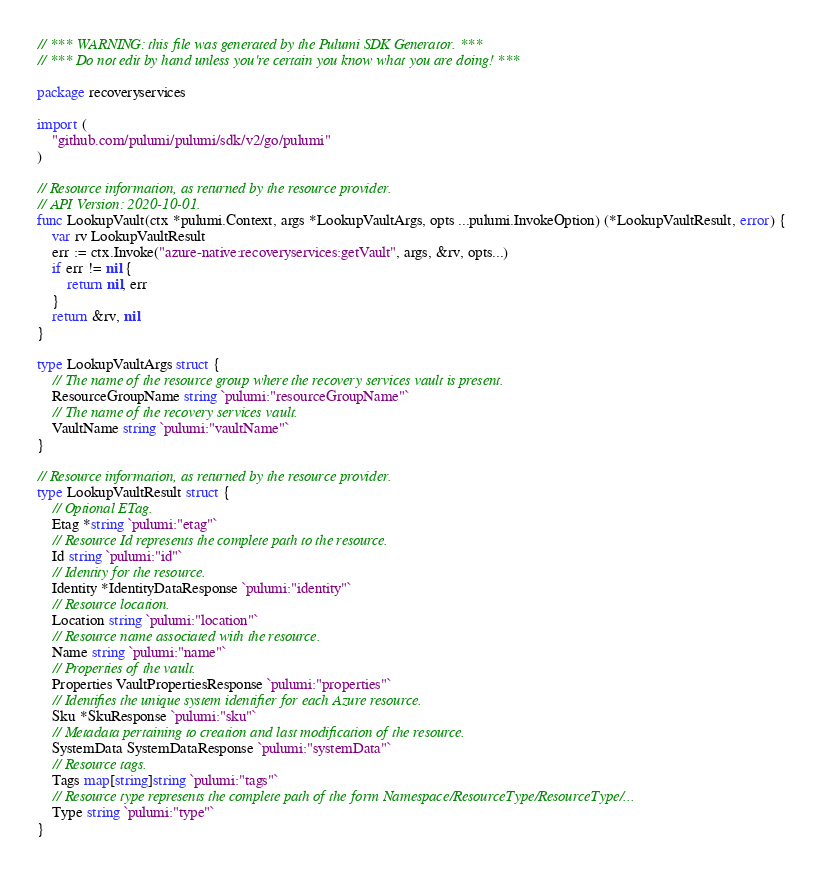<code> <loc_0><loc_0><loc_500><loc_500><_Go_>// *** WARNING: this file was generated by the Pulumi SDK Generator. ***
// *** Do not edit by hand unless you're certain you know what you are doing! ***

package recoveryservices

import (
	"github.com/pulumi/pulumi/sdk/v2/go/pulumi"
)

// Resource information, as returned by the resource provider.
// API Version: 2020-10-01.
func LookupVault(ctx *pulumi.Context, args *LookupVaultArgs, opts ...pulumi.InvokeOption) (*LookupVaultResult, error) {
	var rv LookupVaultResult
	err := ctx.Invoke("azure-native:recoveryservices:getVault", args, &rv, opts...)
	if err != nil {
		return nil, err
	}
	return &rv, nil
}

type LookupVaultArgs struct {
	// The name of the resource group where the recovery services vault is present.
	ResourceGroupName string `pulumi:"resourceGroupName"`
	// The name of the recovery services vault.
	VaultName string `pulumi:"vaultName"`
}

// Resource information, as returned by the resource provider.
type LookupVaultResult struct {
	// Optional ETag.
	Etag *string `pulumi:"etag"`
	// Resource Id represents the complete path to the resource.
	Id string `pulumi:"id"`
	// Identity for the resource.
	Identity *IdentityDataResponse `pulumi:"identity"`
	// Resource location.
	Location string `pulumi:"location"`
	// Resource name associated with the resource.
	Name string `pulumi:"name"`
	// Properties of the vault.
	Properties VaultPropertiesResponse `pulumi:"properties"`
	// Identifies the unique system identifier for each Azure resource.
	Sku *SkuResponse `pulumi:"sku"`
	// Metadata pertaining to creation and last modification of the resource.
	SystemData SystemDataResponse `pulumi:"systemData"`
	// Resource tags.
	Tags map[string]string `pulumi:"tags"`
	// Resource type represents the complete path of the form Namespace/ResourceType/ResourceType/...
	Type string `pulumi:"type"`
}
</code> 